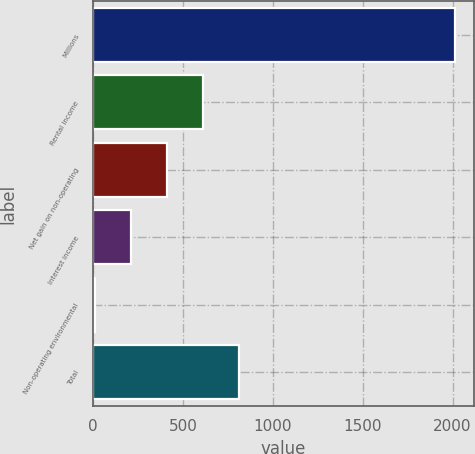Convert chart to OTSL. <chart><loc_0><loc_0><loc_500><loc_500><bar_chart><fcel>Millions<fcel>Rental income<fcel>Net gain on non-operating<fcel>Interest income<fcel>Non-operating environmental<fcel>Total<nl><fcel>2016<fcel>611.1<fcel>410.4<fcel>209.7<fcel>9<fcel>811.8<nl></chart> 